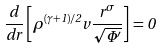Convert formula to latex. <formula><loc_0><loc_0><loc_500><loc_500>\frac { d } { d r } \left [ \rho ^ { ( \gamma + 1 ) / 2 } v \frac { r ^ { \sigma } } { \sqrt { \Phi ^ { \prime } } } \right ] = 0</formula> 